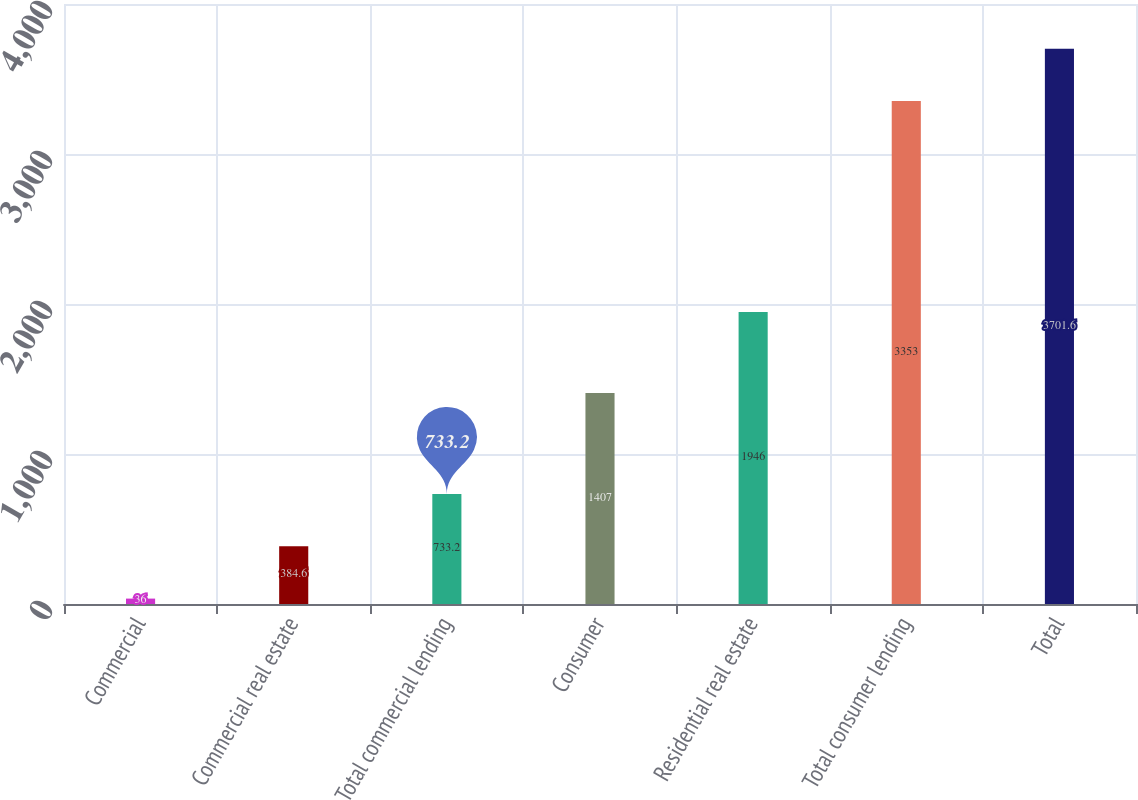<chart> <loc_0><loc_0><loc_500><loc_500><bar_chart><fcel>Commercial<fcel>Commercial real estate<fcel>Total commercial lending<fcel>Consumer<fcel>Residential real estate<fcel>Total consumer lending<fcel>Total<nl><fcel>36<fcel>384.6<fcel>733.2<fcel>1407<fcel>1946<fcel>3353<fcel>3701.6<nl></chart> 